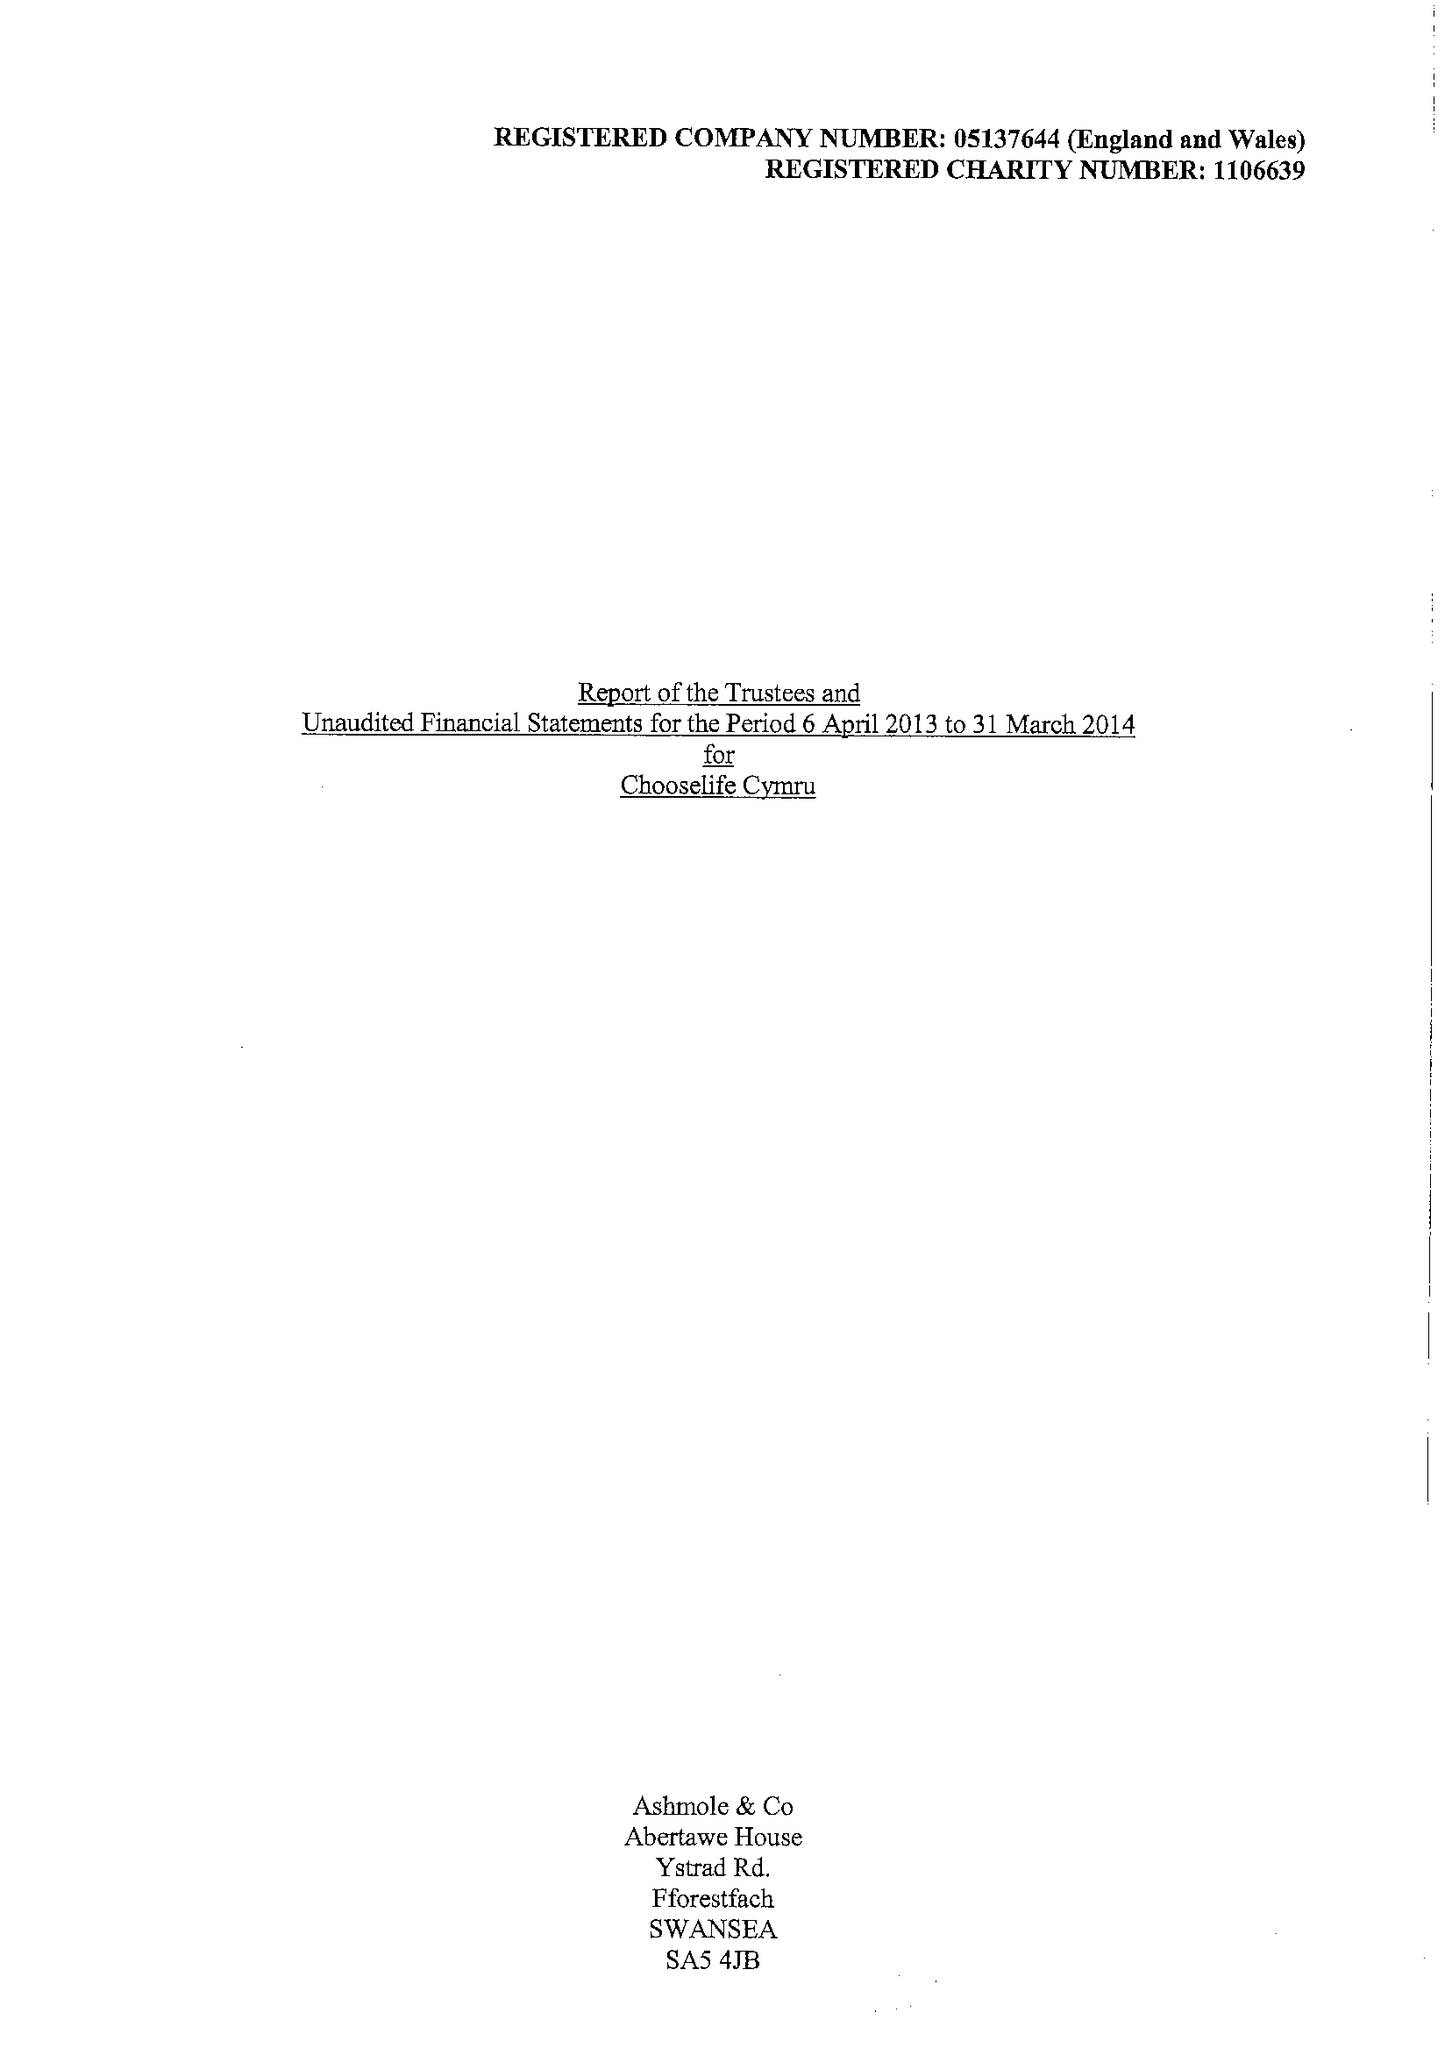What is the value for the report_date?
Answer the question using a single word or phrase. 2014-03-31 